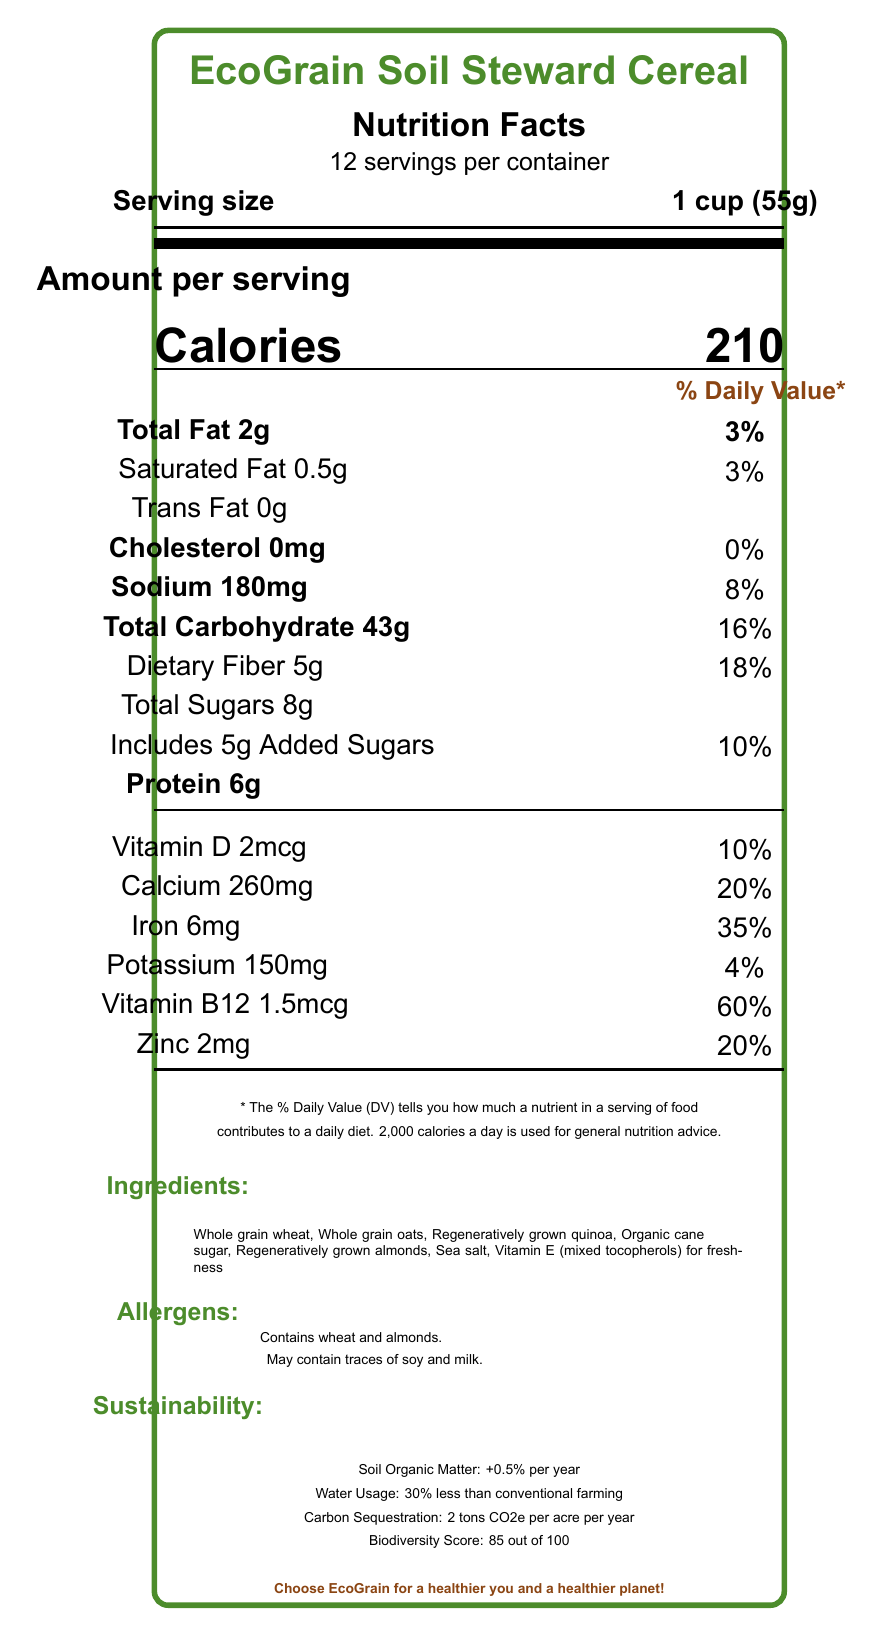what is the serving size? The serving size is clearly stated as "1 cup (55g)" in the document.
Answer: 1 cup (55g) how many servings are in the container? The document specifies there are "12 servings per container".
Answer: 12 how many grams of protein are in one serving? The amount of protein per serving is listed as "Protein 6g" in the document.
Answer: 6g what is the daily value percentage for dietary fiber? The daily value percentage for dietary fiber is listed as "18%" next to "Dietary Fiber 5g".
Answer: 18% how much calcium does one serving provide? The document lists "Calcium 260mg" under the nutritional information section.
Answer: 260mg which of the following statements is true regarding vitamin D in the cereal? A. It provides 5% Daily Value B. It provides 10% Daily Value C. It provides 20% Daily Value The document lists "Vitamin D 2mcg" with a "10%" Daily Value.
Answer: B what ingredients are unequivocally listed as allergens? A. Wheat and soy B. Almonds and milk C. Wheat and almonds The allergens listed are "Contains wheat and almonds".
Answer: C does the cereal contain any cholesterol? The document lists "Cholesterol 0mg", indicating no cholesterol is present in a serving.
Answer: No does the document provide information about the cereal's impact on water usage? The document states that the cereal uses "30% less than conventional farming" in terms of water usage.
Answer: Yes is the nutritional information provided sufficient to determine the cereal's taste? Nutritional information provides details about ingredients and health benefits but does not reflect taste.
Answer: No briefly summarize the main idea of the document The document includes comprehensive nutritional details about the cereal product, along with its sustainability benefits related to soil health, water usage, carbon footprint, and ecological impact. Additionally, it highlights psychological factors that align with eco-conscious consumer values.
Answer: The document provides detailed nutritional facts for EcoGrain Soil Steward Cereal, including serving size, calorie content, vitamin and mineral information, and ingredients. It also highlights sustainability metrics such as soil health benefits, reduced water usage, and carbon sequestration, and explains how the product supports eco-conscious consumer behavior. what is the cereal's biodiversity score out of 100? The biodiversity score is listed as "85 out of 100" in the sustainability metrics section.
Answer: 85 what is the environmental benefit mentioned in terms of carbon sequestration? The environmental benefit in terms of carbon sequestration is listed as "2 tons CO2e per acre per year".
Answer: 2 tons CO2e per acre per year does the packaging of the cereal contribute to sustainability? The document mentions that the packaging is "100% recyclable and made from 80% post-consumer recycled materials".
Answer: Yes how does the product aim to reduce eco-anxiety among consumers? The document states that it reduces eco-anxiety by "Empowering consumers to make a positive environmental impact".
Answer: Empowers consumers to make a positive environmental impact 